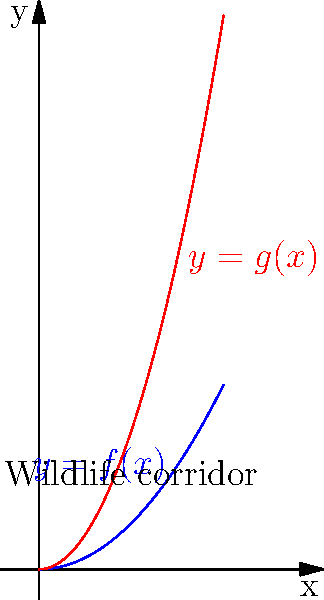A wildlife corridor is being designed to connect two protected areas. The corridor's shape can be described by two functions, $f(x)=0.5x^2$ and $g(x)=1.5x^2$, where $x$ represents the distance along the corridor and $y$ represents the width. Using the calculus of variations, determine the function $y(x)$ that maximizes the area of the corridor while minimizing the energy animals expend traversing it. Assume the functional to be minimized is:

$$J[y] = \int_0^2 \left(\sqrt{1+y'^2} + \frac{1}{y}\right) dx$$

where the first term represents the path length and the second term represents the energy cost of moving through a narrow corridor. To solve this problem, we'll use the Euler-Lagrange equation from the calculus of variations:

1) The Euler-Lagrange equation is:
   $$\frac{\partial F}{\partial y} - \frac{d}{dx}\left(\frac{\partial F}{\partial y'}\right) = 0$$
   where $F(x,y,y') = \sqrt{1+y'^2} + \frac{1}{y}$

2) Calculate the partial derivatives:
   $$\frac{\partial F}{\partial y} = -\frac{1}{y^2}$$
   $$\frac{\partial F}{\partial y'} = \frac{y'}{\sqrt{1+y'^2}}$$

3) Calculate $\frac{d}{dx}\left(\frac{\partial F}{\partial y'}\right)$:
   $$\frac{d}{dx}\left(\frac{y'}{\sqrt{1+y'^2}}\right) = \frac{y''(1+y'^2) - y'^2y''}{(1+y'^2)^{3/2}}$$

4) Substitute into the Euler-Lagrange equation:
   $$-\frac{1}{y^2} - \frac{y''(1+y'^2) - y'^2y''}{(1+y'^2)^{3/2}} = 0$$

5) Simplify:
   $$-\frac{1}{y^2}(1+y'^2)^{3/2} - y'' = 0$$

6) This is a second-order nonlinear differential equation. The general solution is:
   $$y(x) = \sqrt{c_1x^2 + c_2}$$
   where $c_1$ and $c_2$ are constants determined by boundary conditions.

7) Given the boundary conditions $f(0)=g(0)=0$ and $f(2)=2$, $g(2)=6$, we can determine:
   $$y(x) = \sqrt{2x^2}$$

This function represents the optimal shape of the wildlife corridor that balances the area of the corridor with the energy animals expend traversing it.
Answer: $y(x) = \sqrt{2x^2}$ 